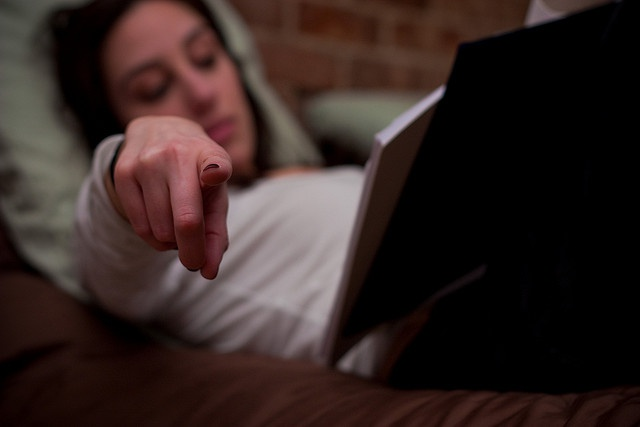Describe the objects in this image and their specific colors. I can see people in black, maroon, darkgray, and gray tones, bed in black and gray tones, and book in black, gray, and darkgray tones in this image. 